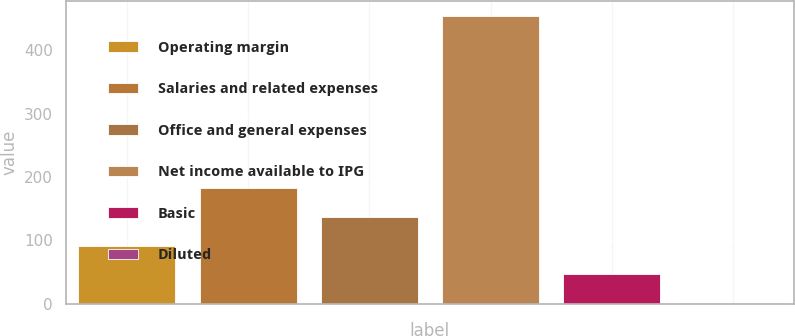Convert chart. <chart><loc_0><loc_0><loc_500><loc_500><bar_chart><fcel>Operating margin<fcel>Salaries and related expenses<fcel>Office and general expenses<fcel>Net income available to IPG<fcel>Basic<fcel>Diluted<nl><fcel>91.79<fcel>182.49<fcel>137.14<fcel>454.6<fcel>46.44<fcel>1.09<nl></chart> 